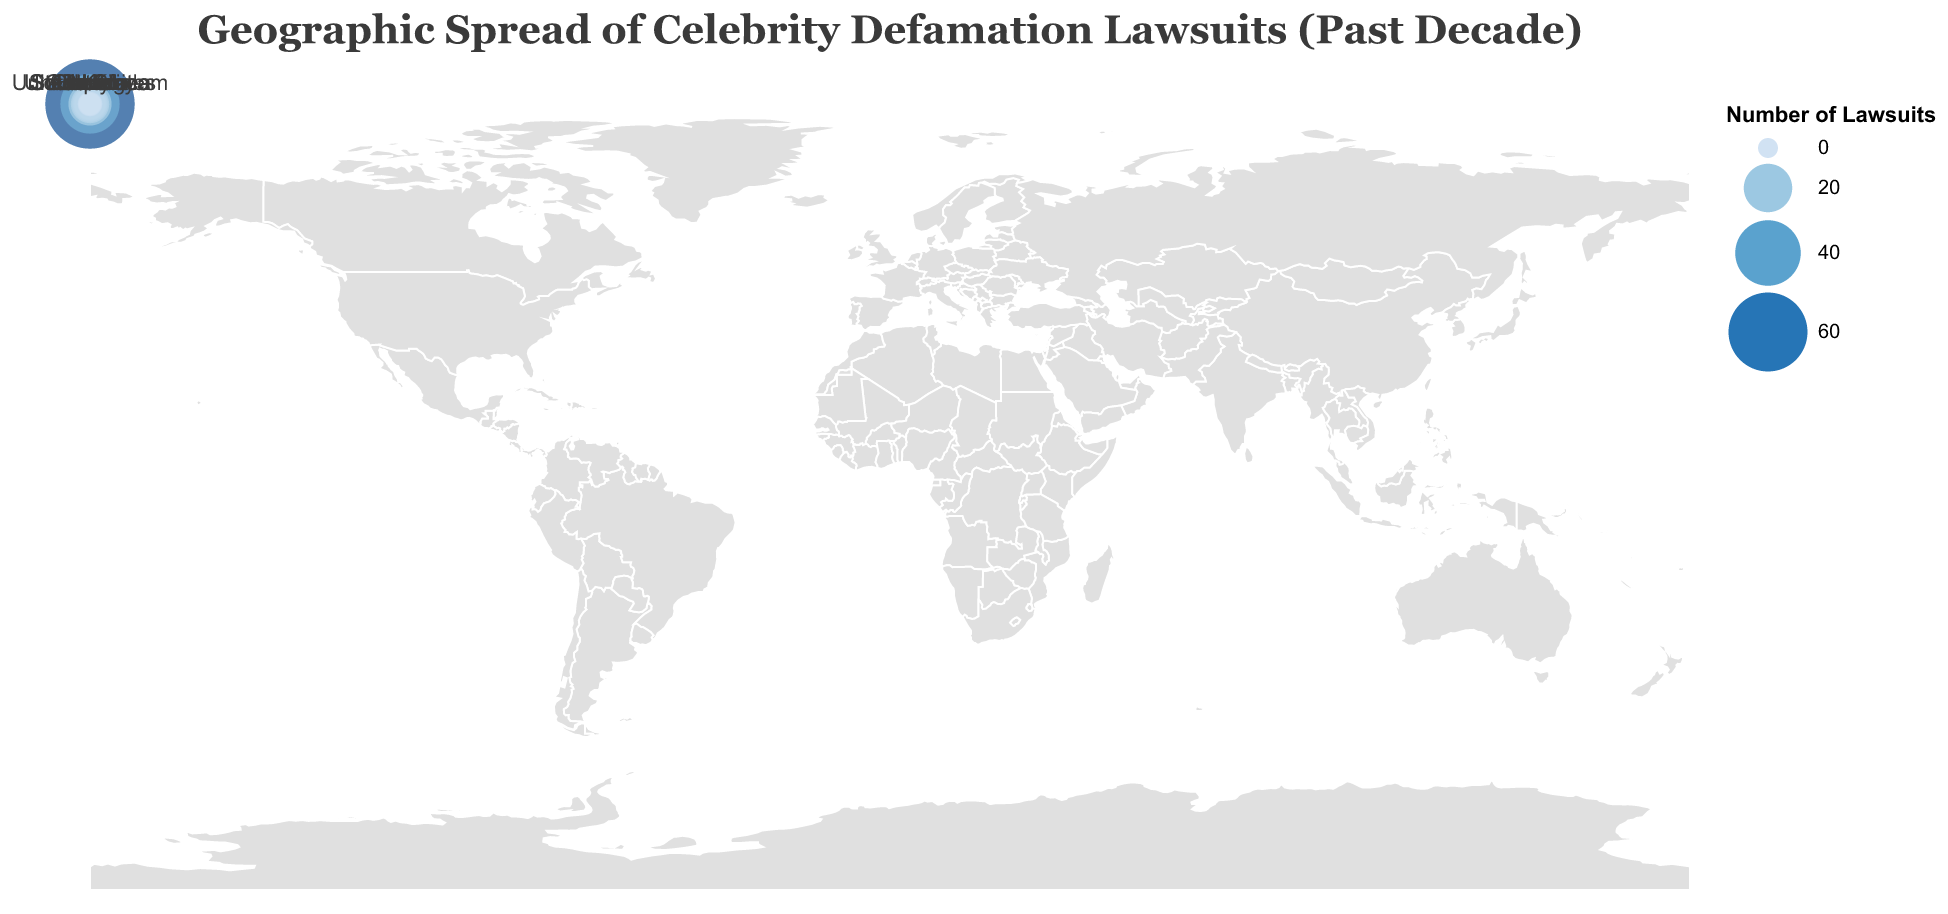How many celebrity defamation lawsuits were filed in the United States? The number of lawsuits in the United States is directly indicated by a data point in the plot.
Answer: 78 Which country has the second highest number of celebrity defamation lawsuits? By examining the data points, the country with the second highest number of lawsuits is the United Kingdom.
Answer: United Kingdom What is the notable defamation case in India? The notable case in India can be identified from the data point related to India in the plot.
Answer: Salman Khan v. NRI Infomedia (2021) Compare the number of lawsuits in Australia and Canada, which one has more? By comparing the data points for Australia and Canada, we see that Australia has more lawsuits than Canada.
Answer: Australia What is the sum of lawsuits from France, Germany, and Italy combined? Adding the number of lawsuits for France (7), Germany (5), and Italy (4): 7 + 5 + 4 = 16.
Answer: 16 How does the number of lawsuits in South Korea compare to Japan? The data points show that South Korea has 6 lawsuits and Japan has 3. Therefore, South Korea has more lawsuits than Japan.
Answer: South Korea What is the notable defamation case in South Africa? The notable case in South Africa can be identified from the data point related to South Africa in the plot.
Answer: Trevor Noah v. Sunday Times (2018) Is the number of lawsuits in Canada greater than 10? The data point for Canada shows 9 lawsuits, which is less than 10.
Answer: No Which country has the least number of celebrity defamation lawsuits? By examining the data, South Africa has the least number of lawsuits with only 1.
Answer: South Africa What is the total number of lawsuits across all countries listed in the dataset? Adding up all the lawsuits: 78 (USA) + 32 (UK) + 15 (Australia) + 9 (Canada) + 7 (France) + 5 (Germany) + 4 (Italy) + 3 (Japan) + 6 (South Korea) + 11 (India) + 2 (Brazil) + 1 (South Africa) = 173.
Answer: 173 